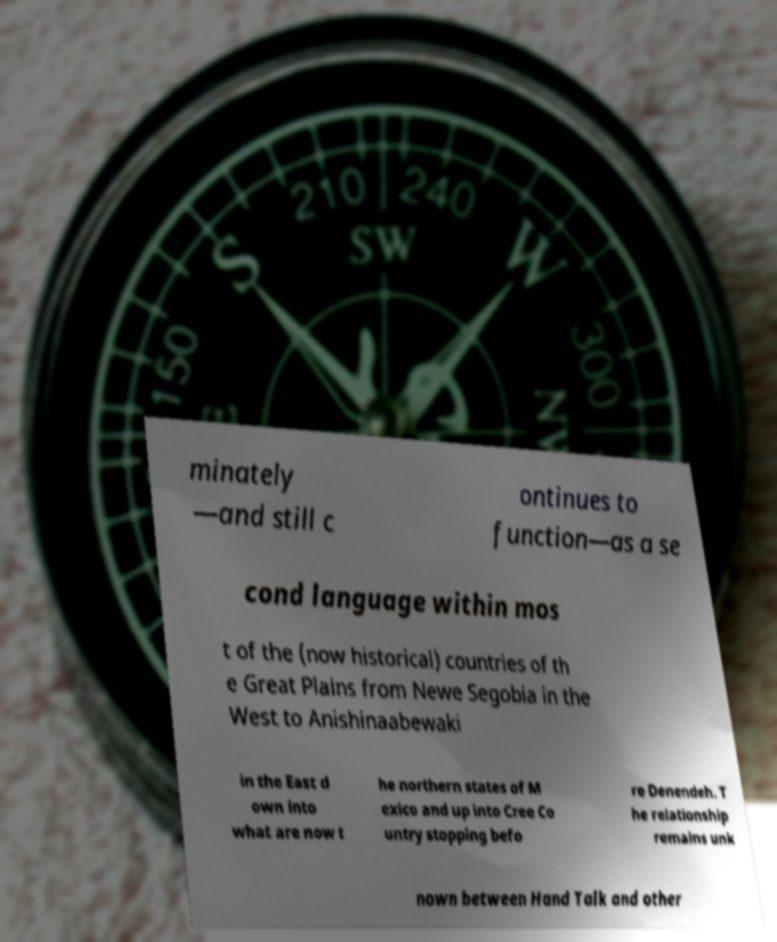There's text embedded in this image that I need extracted. Can you transcribe it verbatim? minately —and still c ontinues to function—as a se cond language within mos t of the (now historical) countries of th e Great Plains from Newe Segobia in the West to Anishinaabewaki in the East d own into what are now t he northern states of M exico and up into Cree Co untry stopping befo re Denendeh. T he relationship remains unk nown between Hand Talk and other 